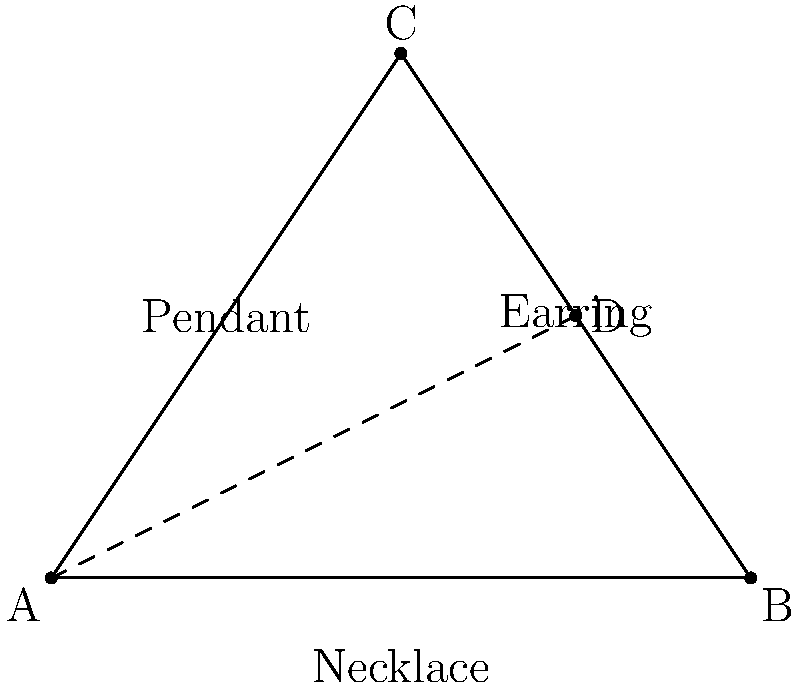In a fashion photoshoot, you've arranged three pieces of triangular jewelry to create a visually appealing composition. The necklace forms the base (AB), while two earrings form the other sides (AC and BC). You place a pendant (D) at the midpoint of side BC. If the area of the entire triangular arrangement is 6 square units, what is the length of AD (the line connecting the necklace's center to the pendant)? Let's approach this step-by-step:

1) Given that D is the midpoint of BC, AD is a median of the triangle.

2) We know from the properties of medians that AD divides the triangle into two equal areas.

3) The area of triangle ABD is half of the total area:
   Area of ABD = 6/2 = 3 square units

4) We can use the formula for the area of a triangle:
   Area = $\frac{1}{2} \times$ base $\times$ height

5) In this case, AB is the base, and AD is the height. Let's call the length of AD 'x':
   3 = $\frac{1}{2} \times$ AB $\times$ x

6) To find AB, we can use the area of the whole triangle:
   6 = $\frac{1}{2} \times$ AB $\times$ height of ABC
   The height of ABC is 1.5 times x (because D is at the midpoint of BC)
   6 = $\frac{1}{2} \times$ AB $\times$ 1.5x
   AB = 8/x

7) Substituting this back into the equation from step 5:
   3 = $\frac{1}{2} \times \frac{8}{x} \times$ x
   3 = 4
   
8) This confirms our calculations. Now we can solve for x:
   3 = $\frac{1}{2} \times$ 8 $\times \frac{1}{x}$
   x = $\frac{8}{6} = \frac{4}{3}$

Therefore, the length of AD is $\frac{4}{3}$ units.
Answer: $\frac{4}{3}$ units 